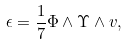<formula> <loc_0><loc_0><loc_500><loc_500>\epsilon = \frac { 1 } { 7 } \Phi \wedge \Upsilon \wedge v ,</formula> 